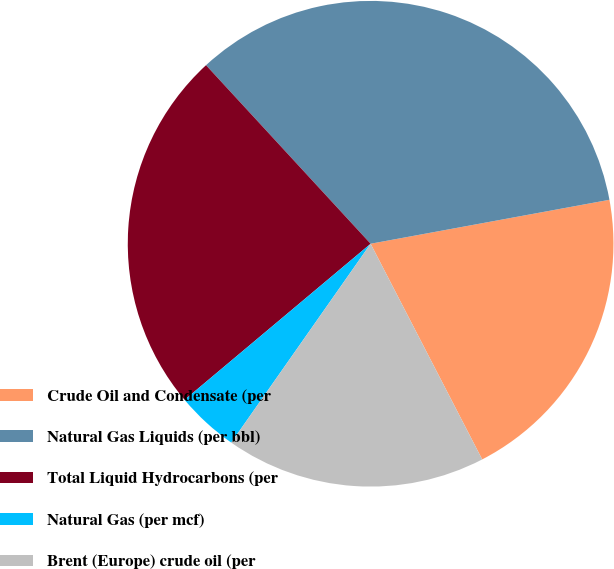<chart> <loc_0><loc_0><loc_500><loc_500><pie_chart><fcel>Crude Oil and Condensate (per<fcel>Natural Gas Liquids (per bbl)<fcel>Total Liquid Hydrocarbons (per<fcel>Natural Gas (per mcf)<fcel>Brent (Europe) crude oil (per<nl><fcel>20.3%<fcel>33.96%<fcel>24.26%<fcel>4.16%<fcel>17.33%<nl></chart> 